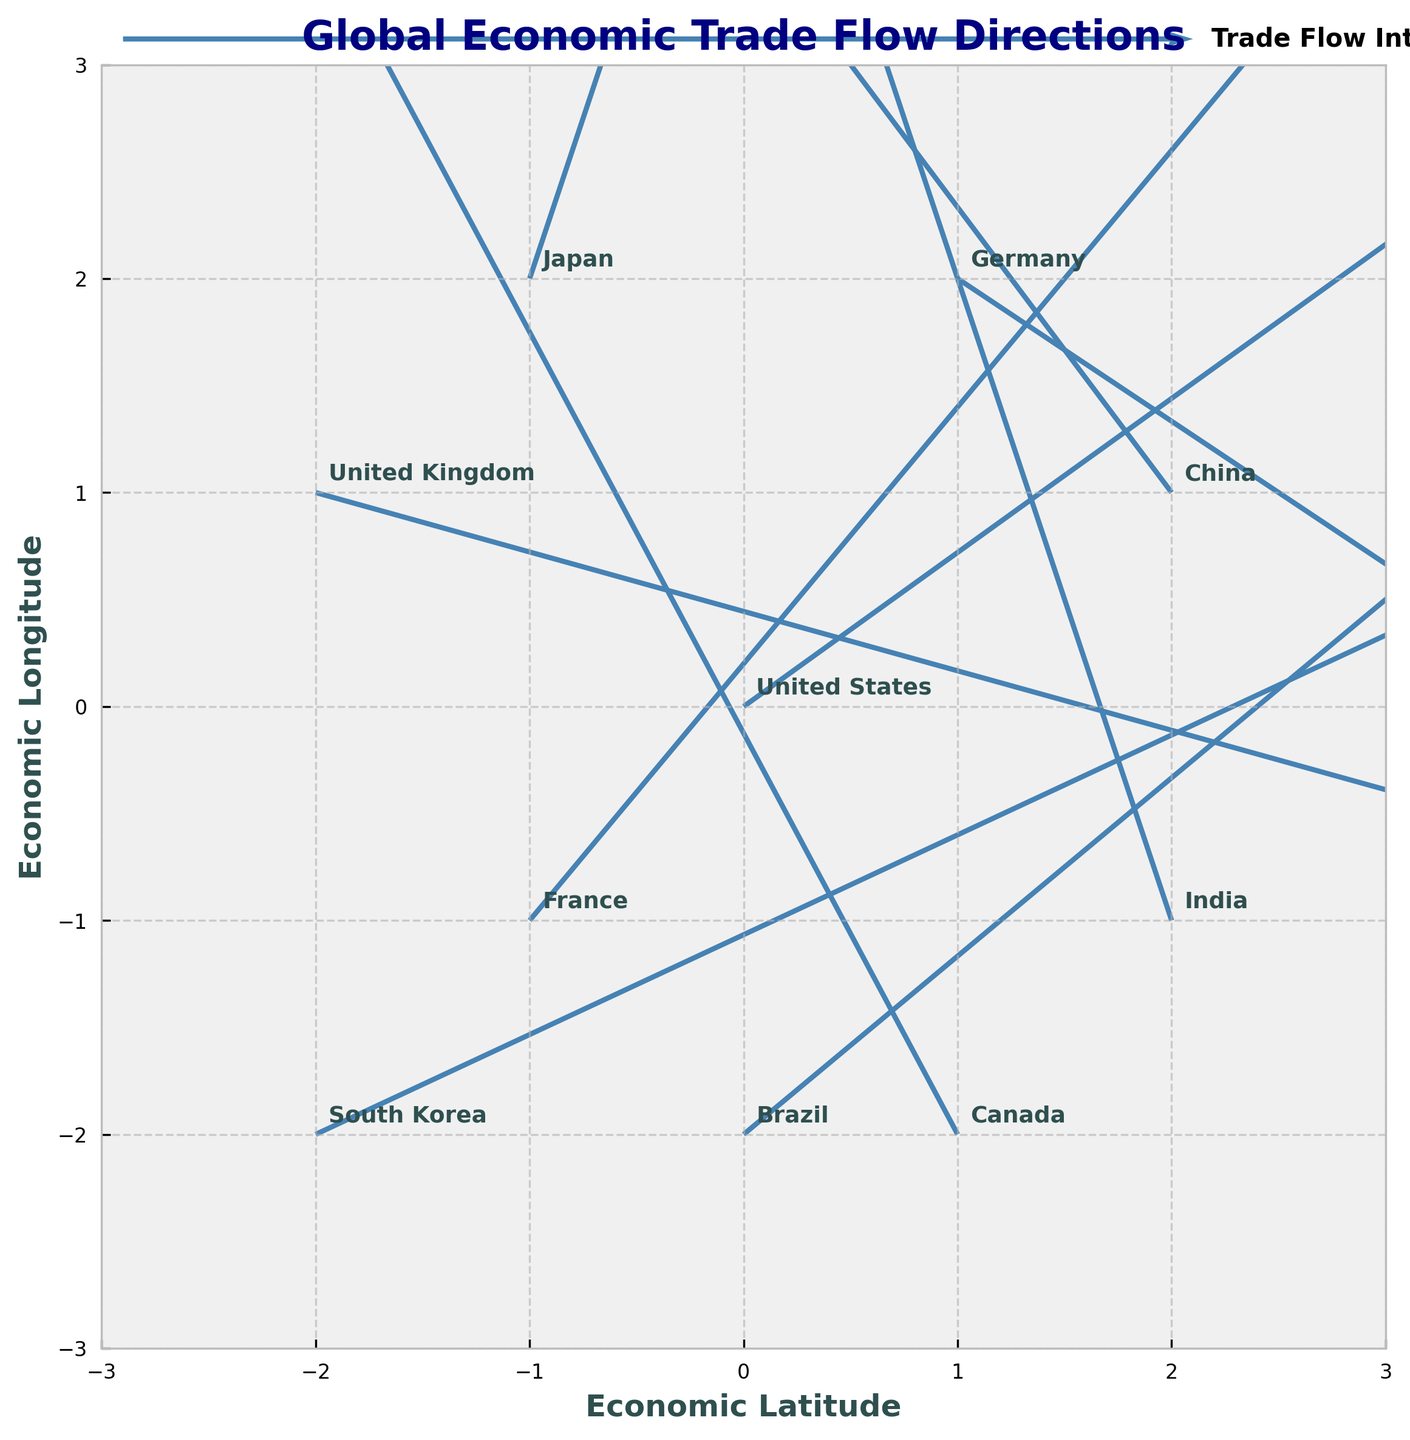How many arrows are shown in the plot? Counting the number of arrows will give the number of data points. Each arrow represents a country's trade flow direction.
Answer: 10 Which country has the most significant positive horizontal trade flow? Determine the country with the highest positive U value. The U component represents the horizontal direction of trade flow. The United States has the highest U value of 2.5.
Answer: United States Which country's trade flow points directly to the left? Identify the country with a negative U value and a V value of approximately zero, pointing directly left. Canada has U = -0.8 and V = 1.5 but does not point directly left. No country has a U value with V approximately zero.
Answer: None What is the shortest trade flow arrow and which country does it represent? Assess the length of each arrow using the Pythagorean theorem (√(U² + V²)) and find the minimum value. Germany has the shortest arrow with U = 1.2 and V = -0.8, giving a length of √(1.44 + 0.64) ≈ 1.44.
Answer: Germany Which two countries have trade flows that start from negative coordinates? Identify countries with both X and Y coordinates less than zero. Japan (-1, 2) and South Korea (-2, -2) fit this criterion.
Answer: Japan, South Korea How is the trade flow direction of India different from that of China? Compare the U and V values of India and China. India's (U, V) = (-0.6, 1.8) and China's (U, V) = (-1.5, 2.0). China has a more negative horizontal component and a slightly higher vertical component.
Answer: More negative U, slightly higher V Between Brazil and Canada, which country has a more upward trade flow direction? Compare the V values. Brazil has V = 1.0, and Canada has V = 1.5. Higher V indicates a more upward direction.
Answer: Canada Which countries' trade flows have components in both negative directions? Find countries with both U and V values negative. None of the countries listed have both negative U and V values.
Answer: None Are there any trade flows that are purely horizontal or purely vertical? Check if any country's U or V value is zero, indicating a purely horizontal or vertical direction. None of the U or V values are zero in the data provided.
Answer: None 